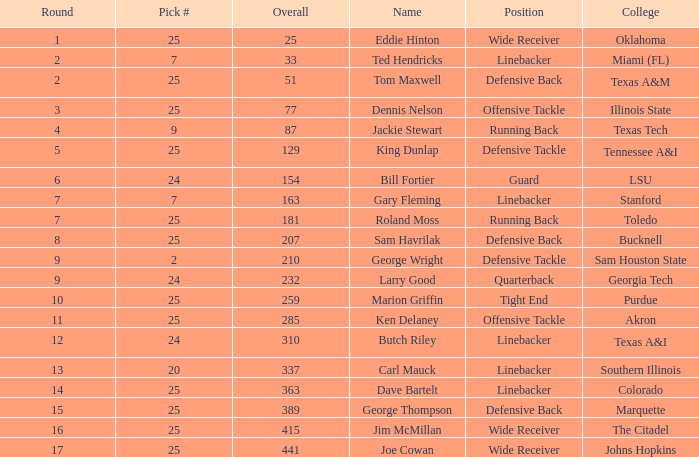What is the name for a selection of 25 out of 207 overall? Sam Havrilak. 